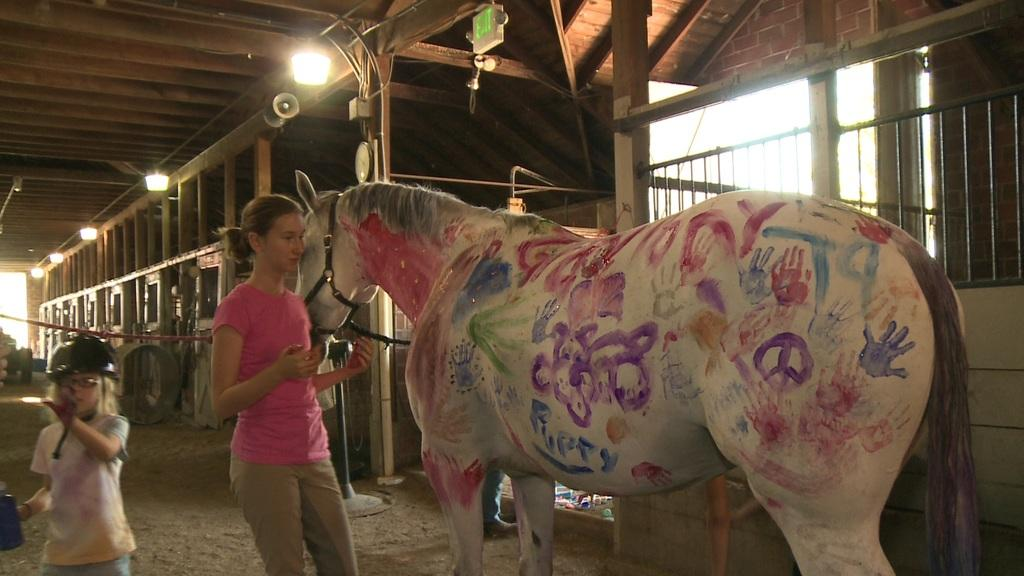What type of structure is present in the image? There is a stable in the image. Who is present in the image? There is a woman and a girl in the image. What animal is in the image? There is a horse in the image. What is the girl doing in the image? The girl is standing in the image. What can be seen in the image that provides illumination? There are lights visible in the image. What type of crow is sitting on the school in the image? There is no crow or school present in the image. What might surprise the girl in the image? It is impossible to determine what might surprise the girl in the image based on the provided facts. 